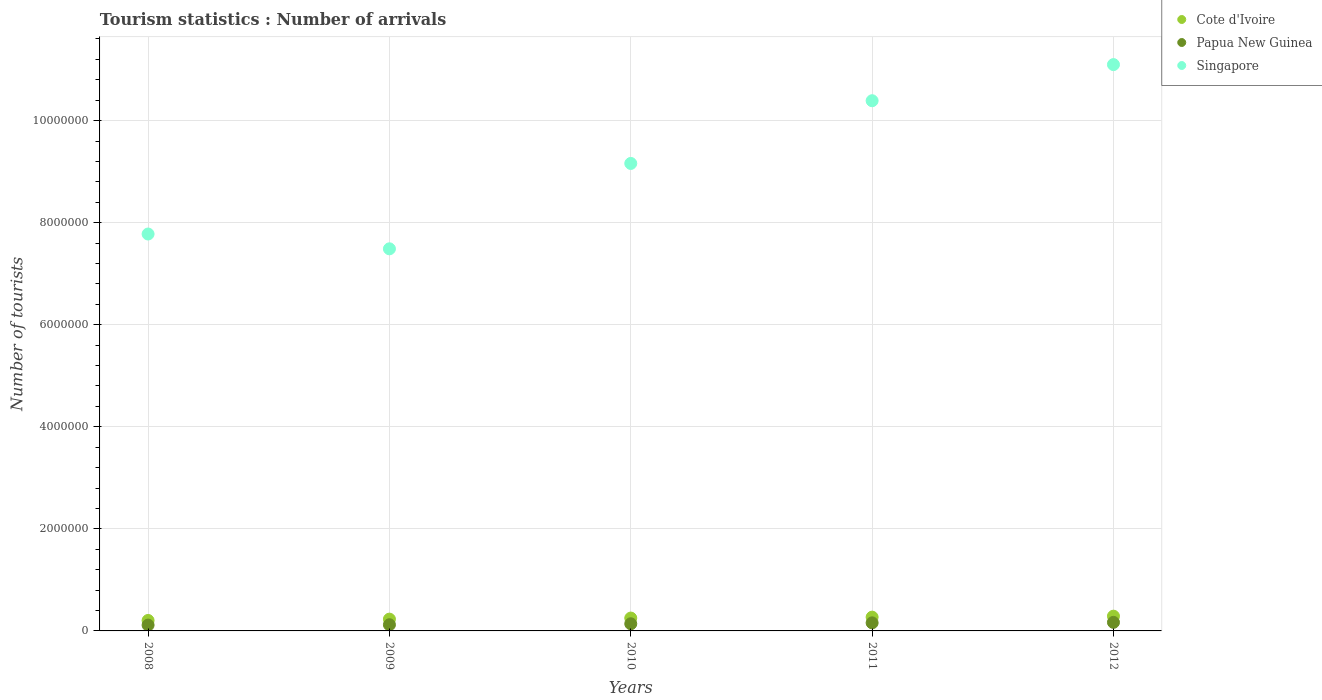How many different coloured dotlines are there?
Your answer should be compact. 3. What is the number of tourist arrivals in Papua New Guinea in 2012?
Make the answer very short. 1.68e+05. Across all years, what is the maximum number of tourist arrivals in Singapore?
Your response must be concise. 1.11e+07. Across all years, what is the minimum number of tourist arrivals in Papua New Guinea?
Your response must be concise. 1.14e+05. In which year was the number of tourist arrivals in Cote d'Ivoire maximum?
Your response must be concise. 2012. In which year was the number of tourist arrivals in Singapore minimum?
Offer a terse response. 2009. What is the total number of tourist arrivals in Cote d'Ivoire in the graph?
Provide a succinct answer. 1.25e+06. What is the difference between the number of tourist arrivals in Cote d'Ivoire in 2011 and that in 2012?
Ensure brevity in your answer.  -1.90e+04. What is the difference between the number of tourist arrivals in Cote d'Ivoire in 2010 and the number of tourist arrivals in Singapore in 2009?
Your response must be concise. -7.24e+06. What is the average number of tourist arrivals in Singapore per year?
Offer a terse response. 9.18e+06. In the year 2009, what is the difference between the number of tourist arrivals in Cote d'Ivoire and number of tourist arrivals in Papua New Guinea?
Give a very brief answer. 1.10e+05. In how many years, is the number of tourist arrivals in Singapore greater than 7200000?
Your answer should be compact. 5. What is the ratio of the number of tourist arrivals in Cote d'Ivoire in 2009 to that in 2010?
Your answer should be very brief. 0.92. Is the number of tourist arrivals in Cote d'Ivoire in 2010 less than that in 2011?
Keep it short and to the point. Yes. What is the difference between the highest and the second highest number of tourist arrivals in Cote d'Ivoire?
Offer a terse response. 1.90e+04. What is the difference between the highest and the lowest number of tourist arrivals in Singapore?
Provide a short and direct response. 3.61e+06. Is the sum of the number of tourist arrivals in Cote d'Ivoire in 2009 and 2010 greater than the maximum number of tourist arrivals in Papua New Guinea across all years?
Your answer should be compact. Yes. How many dotlines are there?
Keep it short and to the point. 3. How many years are there in the graph?
Give a very brief answer. 5. How many legend labels are there?
Give a very brief answer. 3. How are the legend labels stacked?
Keep it short and to the point. Vertical. What is the title of the graph?
Give a very brief answer. Tourism statistics : Number of arrivals. What is the label or title of the X-axis?
Your response must be concise. Years. What is the label or title of the Y-axis?
Offer a terse response. Number of tourists. What is the Number of tourists in Cote d'Ivoire in 2008?
Keep it short and to the point. 2.05e+05. What is the Number of tourists in Papua New Guinea in 2008?
Your response must be concise. 1.14e+05. What is the Number of tourists of Singapore in 2008?
Your answer should be compact. 7.78e+06. What is the Number of tourists of Cote d'Ivoire in 2009?
Your response must be concise. 2.31e+05. What is the Number of tourists of Papua New Guinea in 2009?
Offer a terse response. 1.21e+05. What is the Number of tourists in Singapore in 2009?
Keep it short and to the point. 7.49e+06. What is the Number of tourists in Cote d'Ivoire in 2010?
Your answer should be very brief. 2.52e+05. What is the Number of tourists of Singapore in 2010?
Your response must be concise. 9.16e+06. What is the Number of tourists in Papua New Guinea in 2011?
Offer a terse response. 1.58e+05. What is the Number of tourists in Singapore in 2011?
Your answer should be compact. 1.04e+07. What is the Number of tourists of Cote d'Ivoire in 2012?
Your response must be concise. 2.89e+05. What is the Number of tourists of Papua New Guinea in 2012?
Ensure brevity in your answer.  1.68e+05. What is the Number of tourists of Singapore in 2012?
Provide a succinct answer. 1.11e+07. Across all years, what is the maximum Number of tourists in Cote d'Ivoire?
Ensure brevity in your answer.  2.89e+05. Across all years, what is the maximum Number of tourists in Papua New Guinea?
Ensure brevity in your answer.  1.68e+05. Across all years, what is the maximum Number of tourists in Singapore?
Ensure brevity in your answer.  1.11e+07. Across all years, what is the minimum Number of tourists in Cote d'Ivoire?
Your response must be concise. 2.05e+05. Across all years, what is the minimum Number of tourists of Papua New Guinea?
Your answer should be compact. 1.14e+05. Across all years, what is the minimum Number of tourists of Singapore?
Provide a succinct answer. 7.49e+06. What is the total Number of tourists in Cote d'Ivoire in the graph?
Keep it short and to the point. 1.25e+06. What is the total Number of tourists in Papua New Guinea in the graph?
Provide a succinct answer. 7.01e+05. What is the total Number of tourists of Singapore in the graph?
Ensure brevity in your answer.  4.59e+07. What is the difference between the Number of tourists of Cote d'Ivoire in 2008 and that in 2009?
Provide a succinct answer. -2.60e+04. What is the difference between the Number of tourists in Papua New Guinea in 2008 and that in 2009?
Provide a short and direct response. -7000. What is the difference between the Number of tourists in Singapore in 2008 and that in 2009?
Your response must be concise. 2.90e+05. What is the difference between the Number of tourists in Cote d'Ivoire in 2008 and that in 2010?
Your answer should be compact. -4.70e+04. What is the difference between the Number of tourists of Papua New Guinea in 2008 and that in 2010?
Your answer should be very brief. -2.60e+04. What is the difference between the Number of tourists of Singapore in 2008 and that in 2010?
Your response must be concise. -1.38e+06. What is the difference between the Number of tourists of Cote d'Ivoire in 2008 and that in 2011?
Keep it short and to the point. -6.50e+04. What is the difference between the Number of tourists in Papua New Guinea in 2008 and that in 2011?
Your answer should be very brief. -4.40e+04. What is the difference between the Number of tourists in Singapore in 2008 and that in 2011?
Give a very brief answer. -2.61e+06. What is the difference between the Number of tourists in Cote d'Ivoire in 2008 and that in 2012?
Make the answer very short. -8.40e+04. What is the difference between the Number of tourists of Papua New Guinea in 2008 and that in 2012?
Your answer should be compact. -5.40e+04. What is the difference between the Number of tourists of Singapore in 2008 and that in 2012?
Your answer should be very brief. -3.32e+06. What is the difference between the Number of tourists of Cote d'Ivoire in 2009 and that in 2010?
Your response must be concise. -2.10e+04. What is the difference between the Number of tourists in Papua New Guinea in 2009 and that in 2010?
Your response must be concise. -1.90e+04. What is the difference between the Number of tourists in Singapore in 2009 and that in 2010?
Your answer should be compact. -1.67e+06. What is the difference between the Number of tourists in Cote d'Ivoire in 2009 and that in 2011?
Provide a short and direct response. -3.90e+04. What is the difference between the Number of tourists in Papua New Guinea in 2009 and that in 2011?
Give a very brief answer. -3.70e+04. What is the difference between the Number of tourists of Singapore in 2009 and that in 2011?
Offer a terse response. -2.90e+06. What is the difference between the Number of tourists of Cote d'Ivoire in 2009 and that in 2012?
Keep it short and to the point. -5.80e+04. What is the difference between the Number of tourists of Papua New Guinea in 2009 and that in 2012?
Provide a succinct answer. -4.70e+04. What is the difference between the Number of tourists in Singapore in 2009 and that in 2012?
Offer a terse response. -3.61e+06. What is the difference between the Number of tourists in Cote d'Ivoire in 2010 and that in 2011?
Give a very brief answer. -1.80e+04. What is the difference between the Number of tourists in Papua New Guinea in 2010 and that in 2011?
Offer a terse response. -1.80e+04. What is the difference between the Number of tourists in Singapore in 2010 and that in 2011?
Keep it short and to the point. -1.23e+06. What is the difference between the Number of tourists of Cote d'Ivoire in 2010 and that in 2012?
Ensure brevity in your answer.  -3.70e+04. What is the difference between the Number of tourists in Papua New Guinea in 2010 and that in 2012?
Offer a very short reply. -2.80e+04. What is the difference between the Number of tourists in Singapore in 2010 and that in 2012?
Your answer should be compact. -1.94e+06. What is the difference between the Number of tourists in Cote d'Ivoire in 2011 and that in 2012?
Provide a short and direct response. -1.90e+04. What is the difference between the Number of tourists of Papua New Guinea in 2011 and that in 2012?
Keep it short and to the point. -10000. What is the difference between the Number of tourists in Singapore in 2011 and that in 2012?
Your answer should be very brief. -7.08e+05. What is the difference between the Number of tourists in Cote d'Ivoire in 2008 and the Number of tourists in Papua New Guinea in 2009?
Provide a succinct answer. 8.40e+04. What is the difference between the Number of tourists of Cote d'Ivoire in 2008 and the Number of tourists of Singapore in 2009?
Offer a terse response. -7.28e+06. What is the difference between the Number of tourists of Papua New Guinea in 2008 and the Number of tourists of Singapore in 2009?
Provide a short and direct response. -7.37e+06. What is the difference between the Number of tourists of Cote d'Ivoire in 2008 and the Number of tourists of Papua New Guinea in 2010?
Your response must be concise. 6.50e+04. What is the difference between the Number of tourists in Cote d'Ivoire in 2008 and the Number of tourists in Singapore in 2010?
Provide a short and direct response. -8.96e+06. What is the difference between the Number of tourists of Papua New Guinea in 2008 and the Number of tourists of Singapore in 2010?
Offer a terse response. -9.05e+06. What is the difference between the Number of tourists in Cote d'Ivoire in 2008 and the Number of tourists in Papua New Guinea in 2011?
Provide a short and direct response. 4.70e+04. What is the difference between the Number of tourists of Cote d'Ivoire in 2008 and the Number of tourists of Singapore in 2011?
Provide a short and direct response. -1.02e+07. What is the difference between the Number of tourists of Papua New Guinea in 2008 and the Number of tourists of Singapore in 2011?
Offer a very short reply. -1.03e+07. What is the difference between the Number of tourists in Cote d'Ivoire in 2008 and the Number of tourists in Papua New Guinea in 2012?
Keep it short and to the point. 3.70e+04. What is the difference between the Number of tourists of Cote d'Ivoire in 2008 and the Number of tourists of Singapore in 2012?
Provide a short and direct response. -1.09e+07. What is the difference between the Number of tourists in Papua New Guinea in 2008 and the Number of tourists in Singapore in 2012?
Keep it short and to the point. -1.10e+07. What is the difference between the Number of tourists in Cote d'Ivoire in 2009 and the Number of tourists in Papua New Guinea in 2010?
Provide a short and direct response. 9.10e+04. What is the difference between the Number of tourists of Cote d'Ivoire in 2009 and the Number of tourists of Singapore in 2010?
Your answer should be compact. -8.93e+06. What is the difference between the Number of tourists of Papua New Guinea in 2009 and the Number of tourists of Singapore in 2010?
Provide a succinct answer. -9.04e+06. What is the difference between the Number of tourists in Cote d'Ivoire in 2009 and the Number of tourists in Papua New Guinea in 2011?
Give a very brief answer. 7.30e+04. What is the difference between the Number of tourists in Cote d'Ivoire in 2009 and the Number of tourists in Singapore in 2011?
Make the answer very short. -1.02e+07. What is the difference between the Number of tourists of Papua New Guinea in 2009 and the Number of tourists of Singapore in 2011?
Your answer should be compact. -1.03e+07. What is the difference between the Number of tourists in Cote d'Ivoire in 2009 and the Number of tourists in Papua New Guinea in 2012?
Your response must be concise. 6.30e+04. What is the difference between the Number of tourists of Cote d'Ivoire in 2009 and the Number of tourists of Singapore in 2012?
Your answer should be compact. -1.09e+07. What is the difference between the Number of tourists of Papua New Guinea in 2009 and the Number of tourists of Singapore in 2012?
Make the answer very short. -1.10e+07. What is the difference between the Number of tourists in Cote d'Ivoire in 2010 and the Number of tourists in Papua New Guinea in 2011?
Give a very brief answer. 9.40e+04. What is the difference between the Number of tourists in Cote d'Ivoire in 2010 and the Number of tourists in Singapore in 2011?
Offer a terse response. -1.01e+07. What is the difference between the Number of tourists of Papua New Guinea in 2010 and the Number of tourists of Singapore in 2011?
Give a very brief answer. -1.02e+07. What is the difference between the Number of tourists of Cote d'Ivoire in 2010 and the Number of tourists of Papua New Guinea in 2012?
Your response must be concise. 8.40e+04. What is the difference between the Number of tourists in Cote d'Ivoire in 2010 and the Number of tourists in Singapore in 2012?
Ensure brevity in your answer.  -1.08e+07. What is the difference between the Number of tourists in Papua New Guinea in 2010 and the Number of tourists in Singapore in 2012?
Ensure brevity in your answer.  -1.10e+07. What is the difference between the Number of tourists in Cote d'Ivoire in 2011 and the Number of tourists in Papua New Guinea in 2012?
Your response must be concise. 1.02e+05. What is the difference between the Number of tourists of Cote d'Ivoire in 2011 and the Number of tourists of Singapore in 2012?
Give a very brief answer. -1.08e+07. What is the difference between the Number of tourists of Papua New Guinea in 2011 and the Number of tourists of Singapore in 2012?
Offer a very short reply. -1.09e+07. What is the average Number of tourists of Cote d'Ivoire per year?
Your answer should be very brief. 2.49e+05. What is the average Number of tourists in Papua New Guinea per year?
Your answer should be very brief. 1.40e+05. What is the average Number of tourists of Singapore per year?
Your answer should be compact. 9.18e+06. In the year 2008, what is the difference between the Number of tourists in Cote d'Ivoire and Number of tourists in Papua New Guinea?
Provide a succinct answer. 9.10e+04. In the year 2008, what is the difference between the Number of tourists in Cote d'Ivoire and Number of tourists in Singapore?
Your response must be concise. -7.57e+06. In the year 2008, what is the difference between the Number of tourists of Papua New Guinea and Number of tourists of Singapore?
Make the answer very short. -7.66e+06. In the year 2009, what is the difference between the Number of tourists in Cote d'Ivoire and Number of tourists in Papua New Guinea?
Your response must be concise. 1.10e+05. In the year 2009, what is the difference between the Number of tourists of Cote d'Ivoire and Number of tourists of Singapore?
Your answer should be compact. -7.26e+06. In the year 2009, what is the difference between the Number of tourists in Papua New Guinea and Number of tourists in Singapore?
Your answer should be compact. -7.37e+06. In the year 2010, what is the difference between the Number of tourists of Cote d'Ivoire and Number of tourists of Papua New Guinea?
Offer a terse response. 1.12e+05. In the year 2010, what is the difference between the Number of tourists in Cote d'Ivoire and Number of tourists in Singapore?
Your response must be concise. -8.91e+06. In the year 2010, what is the difference between the Number of tourists of Papua New Guinea and Number of tourists of Singapore?
Your answer should be compact. -9.02e+06. In the year 2011, what is the difference between the Number of tourists in Cote d'Ivoire and Number of tourists in Papua New Guinea?
Your response must be concise. 1.12e+05. In the year 2011, what is the difference between the Number of tourists in Cote d'Ivoire and Number of tourists in Singapore?
Offer a very short reply. -1.01e+07. In the year 2011, what is the difference between the Number of tourists of Papua New Guinea and Number of tourists of Singapore?
Offer a very short reply. -1.02e+07. In the year 2012, what is the difference between the Number of tourists of Cote d'Ivoire and Number of tourists of Papua New Guinea?
Give a very brief answer. 1.21e+05. In the year 2012, what is the difference between the Number of tourists of Cote d'Ivoire and Number of tourists of Singapore?
Offer a very short reply. -1.08e+07. In the year 2012, what is the difference between the Number of tourists in Papua New Guinea and Number of tourists in Singapore?
Offer a very short reply. -1.09e+07. What is the ratio of the Number of tourists of Cote d'Ivoire in 2008 to that in 2009?
Provide a short and direct response. 0.89. What is the ratio of the Number of tourists in Papua New Guinea in 2008 to that in 2009?
Give a very brief answer. 0.94. What is the ratio of the Number of tourists of Singapore in 2008 to that in 2009?
Offer a terse response. 1.04. What is the ratio of the Number of tourists in Cote d'Ivoire in 2008 to that in 2010?
Keep it short and to the point. 0.81. What is the ratio of the Number of tourists in Papua New Guinea in 2008 to that in 2010?
Ensure brevity in your answer.  0.81. What is the ratio of the Number of tourists in Singapore in 2008 to that in 2010?
Keep it short and to the point. 0.85. What is the ratio of the Number of tourists in Cote d'Ivoire in 2008 to that in 2011?
Your answer should be very brief. 0.76. What is the ratio of the Number of tourists of Papua New Guinea in 2008 to that in 2011?
Give a very brief answer. 0.72. What is the ratio of the Number of tourists in Singapore in 2008 to that in 2011?
Give a very brief answer. 0.75. What is the ratio of the Number of tourists in Cote d'Ivoire in 2008 to that in 2012?
Give a very brief answer. 0.71. What is the ratio of the Number of tourists of Papua New Guinea in 2008 to that in 2012?
Keep it short and to the point. 0.68. What is the ratio of the Number of tourists of Singapore in 2008 to that in 2012?
Ensure brevity in your answer.  0.7. What is the ratio of the Number of tourists of Cote d'Ivoire in 2009 to that in 2010?
Give a very brief answer. 0.92. What is the ratio of the Number of tourists of Papua New Guinea in 2009 to that in 2010?
Your response must be concise. 0.86. What is the ratio of the Number of tourists of Singapore in 2009 to that in 2010?
Offer a terse response. 0.82. What is the ratio of the Number of tourists of Cote d'Ivoire in 2009 to that in 2011?
Offer a terse response. 0.86. What is the ratio of the Number of tourists of Papua New Guinea in 2009 to that in 2011?
Keep it short and to the point. 0.77. What is the ratio of the Number of tourists in Singapore in 2009 to that in 2011?
Your response must be concise. 0.72. What is the ratio of the Number of tourists in Cote d'Ivoire in 2009 to that in 2012?
Keep it short and to the point. 0.8. What is the ratio of the Number of tourists in Papua New Guinea in 2009 to that in 2012?
Offer a very short reply. 0.72. What is the ratio of the Number of tourists of Singapore in 2009 to that in 2012?
Your answer should be very brief. 0.67. What is the ratio of the Number of tourists of Papua New Guinea in 2010 to that in 2011?
Your answer should be compact. 0.89. What is the ratio of the Number of tourists of Singapore in 2010 to that in 2011?
Ensure brevity in your answer.  0.88. What is the ratio of the Number of tourists of Cote d'Ivoire in 2010 to that in 2012?
Provide a short and direct response. 0.87. What is the ratio of the Number of tourists in Papua New Guinea in 2010 to that in 2012?
Keep it short and to the point. 0.83. What is the ratio of the Number of tourists in Singapore in 2010 to that in 2012?
Your answer should be very brief. 0.83. What is the ratio of the Number of tourists in Cote d'Ivoire in 2011 to that in 2012?
Offer a very short reply. 0.93. What is the ratio of the Number of tourists of Papua New Guinea in 2011 to that in 2012?
Offer a terse response. 0.94. What is the ratio of the Number of tourists in Singapore in 2011 to that in 2012?
Make the answer very short. 0.94. What is the difference between the highest and the second highest Number of tourists in Cote d'Ivoire?
Offer a very short reply. 1.90e+04. What is the difference between the highest and the second highest Number of tourists in Papua New Guinea?
Your answer should be very brief. 10000. What is the difference between the highest and the second highest Number of tourists in Singapore?
Your response must be concise. 7.08e+05. What is the difference between the highest and the lowest Number of tourists in Cote d'Ivoire?
Your answer should be compact. 8.40e+04. What is the difference between the highest and the lowest Number of tourists of Papua New Guinea?
Provide a short and direct response. 5.40e+04. What is the difference between the highest and the lowest Number of tourists in Singapore?
Give a very brief answer. 3.61e+06. 